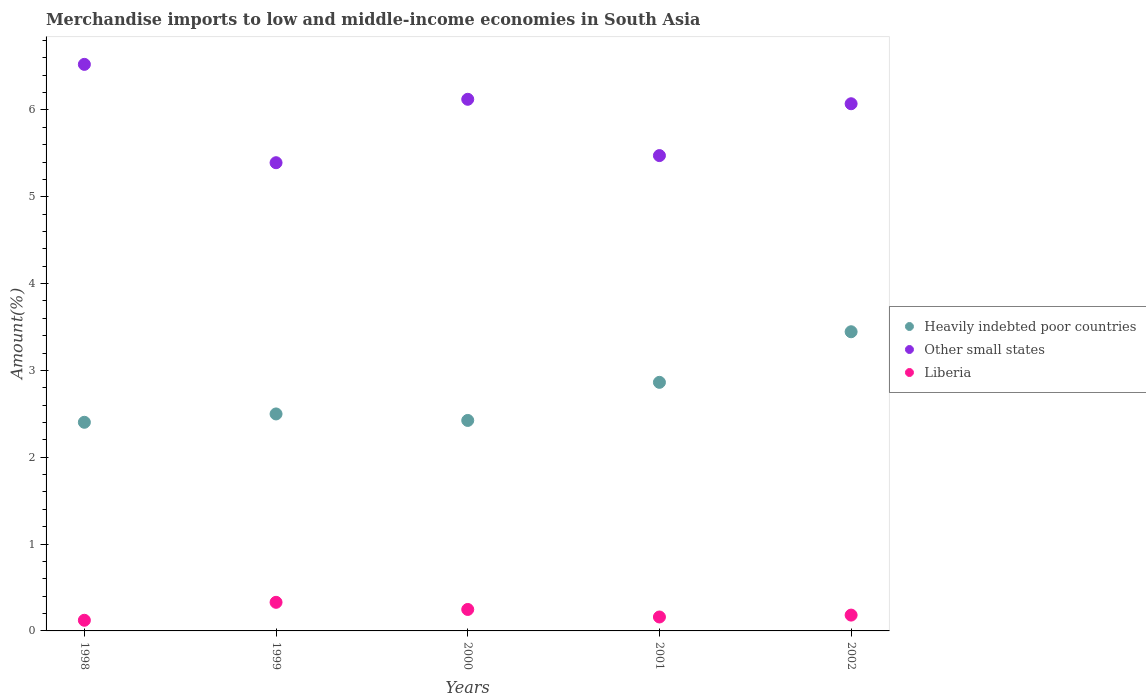How many different coloured dotlines are there?
Provide a succinct answer. 3. What is the percentage of amount earned from merchandise imports in Liberia in 2001?
Give a very brief answer. 0.16. Across all years, what is the maximum percentage of amount earned from merchandise imports in Other small states?
Your answer should be very brief. 6.52. Across all years, what is the minimum percentage of amount earned from merchandise imports in Liberia?
Provide a short and direct response. 0.12. In which year was the percentage of amount earned from merchandise imports in Heavily indebted poor countries maximum?
Your answer should be very brief. 2002. In which year was the percentage of amount earned from merchandise imports in Heavily indebted poor countries minimum?
Give a very brief answer. 1998. What is the total percentage of amount earned from merchandise imports in Liberia in the graph?
Ensure brevity in your answer.  1.04. What is the difference between the percentage of amount earned from merchandise imports in Other small states in 1999 and that in 2002?
Your response must be concise. -0.68. What is the difference between the percentage of amount earned from merchandise imports in Liberia in 1999 and the percentage of amount earned from merchandise imports in Other small states in 2000?
Ensure brevity in your answer.  -5.79. What is the average percentage of amount earned from merchandise imports in Heavily indebted poor countries per year?
Provide a short and direct response. 2.73. In the year 1999, what is the difference between the percentage of amount earned from merchandise imports in Liberia and percentage of amount earned from merchandise imports in Heavily indebted poor countries?
Offer a very short reply. -2.17. What is the ratio of the percentage of amount earned from merchandise imports in Liberia in 1998 to that in 1999?
Your response must be concise. 0.37. What is the difference between the highest and the second highest percentage of amount earned from merchandise imports in Heavily indebted poor countries?
Make the answer very short. 0.58. What is the difference between the highest and the lowest percentage of amount earned from merchandise imports in Other small states?
Provide a short and direct response. 1.13. Is it the case that in every year, the sum of the percentage of amount earned from merchandise imports in Other small states and percentage of amount earned from merchandise imports in Heavily indebted poor countries  is greater than the percentage of amount earned from merchandise imports in Liberia?
Offer a very short reply. Yes. Is the percentage of amount earned from merchandise imports in Other small states strictly greater than the percentage of amount earned from merchandise imports in Liberia over the years?
Give a very brief answer. Yes. Is the percentage of amount earned from merchandise imports in Heavily indebted poor countries strictly less than the percentage of amount earned from merchandise imports in Other small states over the years?
Make the answer very short. Yes. How many years are there in the graph?
Your response must be concise. 5. Does the graph contain grids?
Keep it short and to the point. No. How are the legend labels stacked?
Offer a terse response. Vertical. What is the title of the graph?
Ensure brevity in your answer.  Merchandise imports to low and middle-income economies in South Asia. What is the label or title of the X-axis?
Provide a short and direct response. Years. What is the label or title of the Y-axis?
Offer a very short reply. Amount(%). What is the Amount(%) of Heavily indebted poor countries in 1998?
Keep it short and to the point. 2.4. What is the Amount(%) of Other small states in 1998?
Ensure brevity in your answer.  6.52. What is the Amount(%) in Liberia in 1998?
Your answer should be very brief. 0.12. What is the Amount(%) in Heavily indebted poor countries in 1999?
Make the answer very short. 2.5. What is the Amount(%) in Other small states in 1999?
Your response must be concise. 5.39. What is the Amount(%) in Liberia in 1999?
Provide a short and direct response. 0.33. What is the Amount(%) of Heavily indebted poor countries in 2000?
Your answer should be compact. 2.42. What is the Amount(%) in Other small states in 2000?
Keep it short and to the point. 6.12. What is the Amount(%) in Liberia in 2000?
Keep it short and to the point. 0.25. What is the Amount(%) of Heavily indebted poor countries in 2001?
Keep it short and to the point. 2.86. What is the Amount(%) of Other small states in 2001?
Your response must be concise. 5.47. What is the Amount(%) in Liberia in 2001?
Your answer should be very brief. 0.16. What is the Amount(%) in Heavily indebted poor countries in 2002?
Provide a short and direct response. 3.45. What is the Amount(%) in Other small states in 2002?
Ensure brevity in your answer.  6.07. What is the Amount(%) in Liberia in 2002?
Your response must be concise. 0.18. Across all years, what is the maximum Amount(%) in Heavily indebted poor countries?
Your response must be concise. 3.45. Across all years, what is the maximum Amount(%) in Other small states?
Your answer should be compact. 6.52. Across all years, what is the maximum Amount(%) of Liberia?
Your answer should be very brief. 0.33. Across all years, what is the minimum Amount(%) in Heavily indebted poor countries?
Your answer should be very brief. 2.4. Across all years, what is the minimum Amount(%) of Other small states?
Keep it short and to the point. 5.39. Across all years, what is the minimum Amount(%) in Liberia?
Keep it short and to the point. 0.12. What is the total Amount(%) of Heavily indebted poor countries in the graph?
Give a very brief answer. 13.63. What is the total Amount(%) of Other small states in the graph?
Make the answer very short. 29.58. What is the total Amount(%) of Liberia in the graph?
Your response must be concise. 1.04. What is the difference between the Amount(%) of Heavily indebted poor countries in 1998 and that in 1999?
Offer a very short reply. -0.1. What is the difference between the Amount(%) of Other small states in 1998 and that in 1999?
Offer a terse response. 1.13. What is the difference between the Amount(%) in Liberia in 1998 and that in 1999?
Give a very brief answer. -0.21. What is the difference between the Amount(%) in Heavily indebted poor countries in 1998 and that in 2000?
Give a very brief answer. -0.02. What is the difference between the Amount(%) of Other small states in 1998 and that in 2000?
Your answer should be very brief. 0.4. What is the difference between the Amount(%) in Liberia in 1998 and that in 2000?
Give a very brief answer. -0.12. What is the difference between the Amount(%) of Heavily indebted poor countries in 1998 and that in 2001?
Provide a succinct answer. -0.46. What is the difference between the Amount(%) of Other small states in 1998 and that in 2001?
Your answer should be very brief. 1.05. What is the difference between the Amount(%) in Liberia in 1998 and that in 2001?
Provide a succinct answer. -0.04. What is the difference between the Amount(%) of Heavily indebted poor countries in 1998 and that in 2002?
Your answer should be very brief. -1.04. What is the difference between the Amount(%) in Other small states in 1998 and that in 2002?
Your answer should be very brief. 0.45. What is the difference between the Amount(%) of Liberia in 1998 and that in 2002?
Offer a very short reply. -0.06. What is the difference between the Amount(%) in Heavily indebted poor countries in 1999 and that in 2000?
Your response must be concise. 0.07. What is the difference between the Amount(%) in Other small states in 1999 and that in 2000?
Your response must be concise. -0.73. What is the difference between the Amount(%) in Liberia in 1999 and that in 2000?
Your answer should be very brief. 0.08. What is the difference between the Amount(%) in Heavily indebted poor countries in 1999 and that in 2001?
Give a very brief answer. -0.36. What is the difference between the Amount(%) in Other small states in 1999 and that in 2001?
Your answer should be very brief. -0.08. What is the difference between the Amount(%) in Liberia in 1999 and that in 2001?
Give a very brief answer. 0.17. What is the difference between the Amount(%) of Heavily indebted poor countries in 1999 and that in 2002?
Your response must be concise. -0.95. What is the difference between the Amount(%) in Other small states in 1999 and that in 2002?
Keep it short and to the point. -0.68. What is the difference between the Amount(%) of Liberia in 1999 and that in 2002?
Your answer should be very brief. 0.15. What is the difference between the Amount(%) in Heavily indebted poor countries in 2000 and that in 2001?
Ensure brevity in your answer.  -0.44. What is the difference between the Amount(%) of Other small states in 2000 and that in 2001?
Keep it short and to the point. 0.65. What is the difference between the Amount(%) in Liberia in 2000 and that in 2001?
Make the answer very short. 0.09. What is the difference between the Amount(%) of Heavily indebted poor countries in 2000 and that in 2002?
Offer a very short reply. -1.02. What is the difference between the Amount(%) of Other small states in 2000 and that in 2002?
Your answer should be very brief. 0.05. What is the difference between the Amount(%) of Liberia in 2000 and that in 2002?
Ensure brevity in your answer.  0.07. What is the difference between the Amount(%) of Heavily indebted poor countries in 2001 and that in 2002?
Ensure brevity in your answer.  -0.58. What is the difference between the Amount(%) of Other small states in 2001 and that in 2002?
Keep it short and to the point. -0.6. What is the difference between the Amount(%) in Liberia in 2001 and that in 2002?
Ensure brevity in your answer.  -0.02. What is the difference between the Amount(%) in Heavily indebted poor countries in 1998 and the Amount(%) in Other small states in 1999?
Offer a very short reply. -2.99. What is the difference between the Amount(%) of Heavily indebted poor countries in 1998 and the Amount(%) of Liberia in 1999?
Keep it short and to the point. 2.07. What is the difference between the Amount(%) of Other small states in 1998 and the Amount(%) of Liberia in 1999?
Ensure brevity in your answer.  6.2. What is the difference between the Amount(%) of Heavily indebted poor countries in 1998 and the Amount(%) of Other small states in 2000?
Make the answer very short. -3.72. What is the difference between the Amount(%) of Heavily indebted poor countries in 1998 and the Amount(%) of Liberia in 2000?
Make the answer very short. 2.16. What is the difference between the Amount(%) in Other small states in 1998 and the Amount(%) in Liberia in 2000?
Provide a short and direct response. 6.28. What is the difference between the Amount(%) in Heavily indebted poor countries in 1998 and the Amount(%) in Other small states in 2001?
Your response must be concise. -3.07. What is the difference between the Amount(%) in Heavily indebted poor countries in 1998 and the Amount(%) in Liberia in 2001?
Your answer should be very brief. 2.24. What is the difference between the Amount(%) of Other small states in 1998 and the Amount(%) of Liberia in 2001?
Provide a short and direct response. 6.36. What is the difference between the Amount(%) in Heavily indebted poor countries in 1998 and the Amount(%) in Other small states in 2002?
Offer a very short reply. -3.67. What is the difference between the Amount(%) of Heavily indebted poor countries in 1998 and the Amount(%) of Liberia in 2002?
Provide a succinct answer. 2.22. What is the difference between the Amount(%) in Other small states in 1998 and the Amount(%) in Liberia in 2002?
Make the answer very short. 6.34. What is the difference between the Amount(%) in Heavily indebted poor countries in 1999 and the Amount(%) in Other small states in 2000?
Offer a very short reply. -3.62. What is the difference between the Amount(%) in Heavily indebted poor countries in 1999 and the Amount(%) in Liberia in 2000?
Keep it short and to the point. 2.25. What is the difference between the Amount(%) in Other small states in 1999 and the Amount(%) in Liberia in 2000?
Ensure brevity in your answer.  5.14. What is the difference between the Amount(%) in Heavily indebted poor countries in 1999 and the Amount(%) in Other small states in 2001?
Offer a very short reply. -2.98. What is the difference between the Amount(%) in Heavily indebted poor countries in 1999 and the Amount(%) in Liberia in 2001?
Your response must be concise. 2.34. What is the difference between the Amount(%) of Other small states in 1999 and the Amount(%) of Liberia in 2001?
Your response must be concise. 5.23. What is the difference between the Amount(%) of Heavily indebted poor countries in 1999 and the Amount(%) of Other small states in 2002?
Offer a very short reply. -3.57. What is the difference between the Amount(%) in Heavily indebted poor countries in 1999 and the Amount(%) in Liberia in 2002?
Your response must be concise. 2.32. What is the difference between the Amount(%) of Other small states in 1999 and the Amount(%) of Liberia in 2002?
Provide a succinct answer. 5.21. What is the difference between the Amount(%) of Heavily indebted poor countries in 2000 and the Amount(%) of Other small states in 2001?
Your answer should be compact. -3.05. What is the difference between the Amount(%) of Heavily indebted poor countries in 2000 and the Amount(%) of Liberia in 2001?
Your answer should be very brief. 2.26. What is the difference between the Amount(%) of Other small states in 2000 and the Amount(%) of Liberia in 2001?
Keep it short and to the point. 5.96. What is the difference between the Amount(%) of Heavily indebted poor countries in 2000 and the Amount(%) of Other small states in 2002?
Offer a very short reply. -3.65. What is the difference between the Amount(%) of Heavily indebted poor countries in 2000 and the Amount(%) of Liberia in 2002?
Ensure brevity in your answer.  2.24. What is the difference between the Amount(%) of Other small states in 2000 and the Amount(%) of Liberia in 2002?
Provide a short and direct response. 5.94. What is the difference between the Amount(%) in Heavily indebted poor countries in 2001 and the Amount(%) in Other small states in 2002?
Your answer should be very brief. -3.21. What is the difference between the Amount(%) in Heavily indebted poor countries in 2001 and the Amount(%) in Liberia in 2002?
Your response must be concise. 2.68. What is the difference between the Amount(%) in Other small states in 2001 and the Amount(%) in Liberia in 2002?
Provide a succinct answer. 5.29. What is the average Amount(%) of Heavily indebted poor countries per year?
Ensure brevity in your answer.  2.73. What is the average Amount(%) in Other small states per year?
Provide a short and direct response. 5.92. What is the average Amount(%) of Liberia per year?
Make the answer very short. 0.21. In the year 1998, what is the difference between the Amount(%) in Heavily indebted poor countries and Amount(%) in Other small states?
Give a very brief answer. -4.12. In the year 1998, what is the difference between the Amount(%) of Heavily indebted poor countries and Amount(%) of Liberia?
Make the answer very short. 2.28. In the year 1998, what is the difference between the Amount(%) of Other small states and Amount(%) of Liberia?
Offer a terse response. 6.4. In the year 1999, what is the difference between the Amount(%) of Heavily indebted poor countries and Amount(%) of Other small states?
Offer a very short reply. -2.89. In the year 1999, what is the difference between the Amount(%) of Heavily indebted poor countries and Amount(%) of Liberia?
Offer a very short reply. 2.17. In the year 1999, what is the difference between the Amount(%) of Other small states and Amount(%) of Liberia?
Give a very brief answer. 5.06. In the year 2000, what is the difference between the Amount(%) in Heavily indebted poor countries and Amount(%) in Other small states?
Provide a short and direct response. -3.7. In the year 2000, what is the difference between the Amount(%) of Heavily indebted poor countries and Amount(%) of Liberia?
Ensure brevity in your answer.  2.18. In the year 2000, what is the difference between the Amount(%) of Other small states and Amount(%) of Liberia?
Ensure brevity in your answer.  5.88. In the year 2001, what is the difference between the Amount(%) of Heavily indebted poor countries and Amount(%) of Other small states?
Your response must be concise. -2.61. In the year 2001, what is the difference between the Amount(%) of Heavily indebted poor countries and Amount(%) of Liberia?
Keep it short and to the point. 2.7. In the year 2001, what is the difference between the Amount(%) in Other small states and Amount(%) in Liberia?
Keep it short and to the point. 5.31. In the year 2002, what is the difference between the Amount(%) of Heavily indebted poor countries and Amount(%) of Other small states?
Offer a terse response. -2.63. In the year 2002, what is the difference between the Amount(%) in Heavily indebted poor countries and Amount(%) in Liberia?
Your response must be concise. 3.26. In the year 2002, what is the difference between the Amount(%) in Other small states and Amount(%) in Liberia?
Make the answer very short. 5.89. What is the ratio of the Amount(%) of Heavily indebted poor countries in 1998 to that in 1999?
Make the answer very short. 0.96. What is the ratio of the Amount(%) in Other small states in 1998 to that in 1999?
Keep it short and to the point. 1.21. What is the ratio of the Amount(%) of Liberia in 1998 to that in 1999?
Keep it short and to the point. 0.37. What is the ratio of the Amount(%) in Other small states in 1998 to that in 2000?
Provide a short and direct response. 1.07. What is the ratio of the Amount(%) of Liberia in 1998 to that in 2000?
Provide a short and direct response. 0.5. What is the ratio of the Amount(%) in Heavily indebted poor countries in 1998 to that in 2001?
Your response must be concise. 0.84. What is the ratio of the Amount(%) in Other small states in 1998 to that in 2001?
Your answer should be very brief. 1.19. What is the ratio of the Amount(%) in Liberia in 1998 to that in 2001?
Give a very brief answer. 0.76. What is the ratio of the Amount(%) of Heavily indebted poor countries in 1998 to that in 2002?
Provide a succinct answer. 0.7. What is the ratio of the Amount(%) in Other small states in 1998 to that in 2002?
Offer a very short reply. 1.07. What is the ratio of the Amount(%) in Liberia in 1998 to that in 2002?
Your answer should be very brief. 0.67. What is the ratio of the Amount(%) of Heavily indebted poor countries in 1999 to that in 2000?
Provide a short and direct response. 1.03. What is the ratio of the Amount(%) in Other small states in 1999 to that in 2000?
Make the answer very short. 0.88. What is the ratio of the Amount(%) of Liberia in 1999 to that in 2000?
Ensure brevity in your answer.  1.33. What is the ratio of the Amount(%) in Heavily indebted poor countries in 1999 to that in 2001?
Ensure brevity in your answer.  0.87. What is the ratio of the Amount(%) of Other small states in 1999 to that in 2001?
Your answer should be very brief. 0.98. What is the ratio of the Amount(%) in Liberia in 1999 to that in 2001?
Your answer should be very brief. 2.05. What is the ratio of the Amount(%) in Heavily indebted poor countries in 1999 to that in 2002?
Offer a terse response. 0.73. What is the ratio of the Amount(%) in Other small states in 1999 to that in 2002?
Ensure brevity in your answer.  0.89. What is the ratio of the Amount(%) of Liberia in 1999 to that in 2002?
Offer a very short reply. 1.81. What is the ratio of the Amount(%) of Heavily indebted poor countries in 2000 to that in 2001?
Offer a very short reply. 0.85. What is the ratio of the Amount(%) of Other small states in 2000 to that in 2001?
Keep it short and to the point. 1.12. What is the ratio of the Amount(%) in Liberia in 2000 to that in 2001?
Your response must be concise. 1.54. What is the ratio of the Amount(%) of Heavily indebted poor countries in 2000 to that in 2002?
Make the answer very short. 0.7. What is the ratio of the Amount(%) of Other small states in 2000 to that in 2002?
Your answer should be very brief. 1.01. What is the ratio of the Amount(%) in Liberia in 2000 to that in 2002?
Offer a very short reply. 1.36. What is the ratio of the Amount(%) of Heavily indebted poor countries in 2001 to that in 2002?
Give a very brief answer. 0.83. What is the ratio of the Amount(%) in Other small states in 2001 to that in 2002?
Your answer should be very brief. 0.9. What is the ratio of the Amount(%) of Liberia in 2001 to that in 2002?
Provide a short and direct response. 0.88. What is the difference between the highest and the second highest Amount(%) in Heavily indebted poor countries?
Provide a succinct answer. 0.58. What is the difference between the highest and the second highest Amount(%) of Other small states?
Offer a very short reply. 0.4. What is the difference between the highest and the second highest Amount(%) in Liberia?
Provide a short and direct response. 0.08. What is the difference between the highest and the lowest Amount(%) of Heavily indebted poor countries?
Keep it short and to the point. 1.04. What is the difference between the highest and the lowest Amount(%) of Other small states?
Your answer should be very brief. 1.13. What is the difference between the highest and the lowest Amount(%) in Liberia?
Your response must be concise. 0.21. 